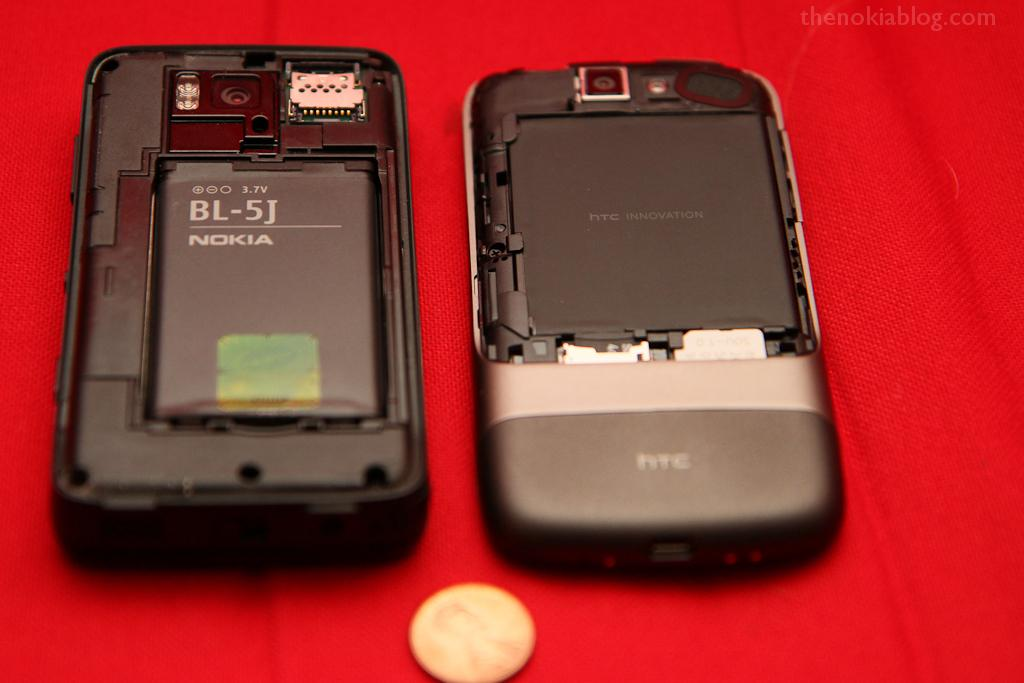<image>
Render a clear and concise summary of the photo. The backs of a Nokia and HTC phone are open on a table. 